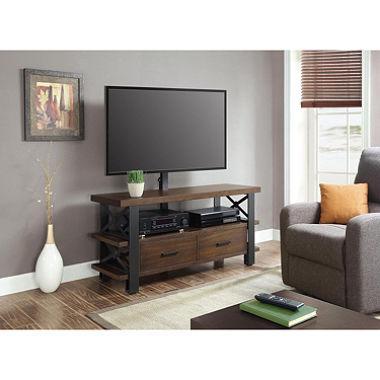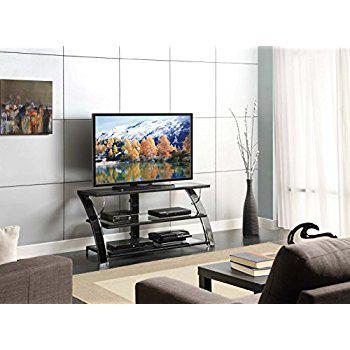The first image is the image on the left, the second image is the image on the right. For the images displayed, is the sentence "Both TV stands have three shelves." factually correct? Answer yes or no. No. The first image is the image on the left, the second image is the image on the right. Examine the images to the left and right. Is the description "The right image features a TV stand with Z-shaped ends formed by a curved diagonal piece, and the left image features a stand with at least one X-shape per end." accurate? Answer yes or no. Yes. 